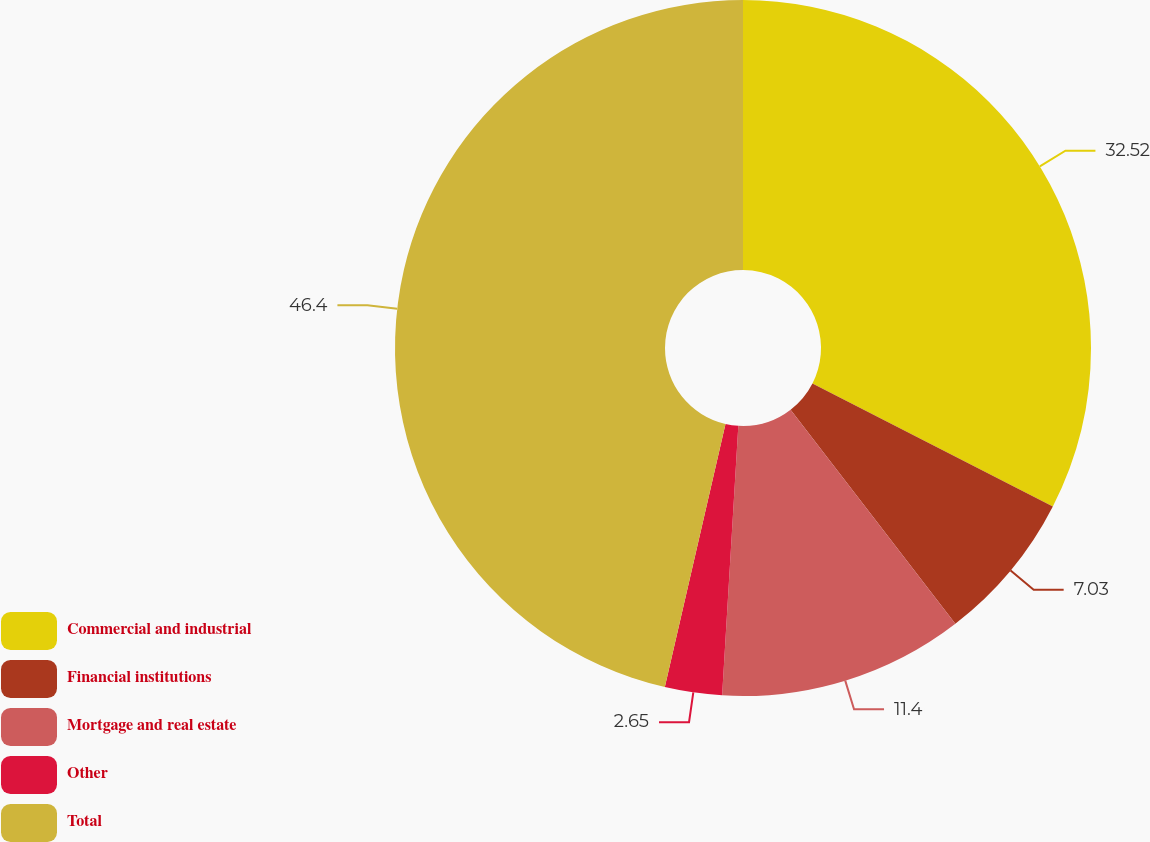Convert chart. <chart><loc_0><loc_0><loc_500><loc_500><pie_chart><fcel>Commercial and industrial<fcel>Financial institutions<fcel>Mortgage and real estate<fcel>Other<fcel>Total<nl><fcel>32.52%<fcel>7.03%<fcel>11.4%<fcel>2.65%<fcel>46.39%<nl></chart> 